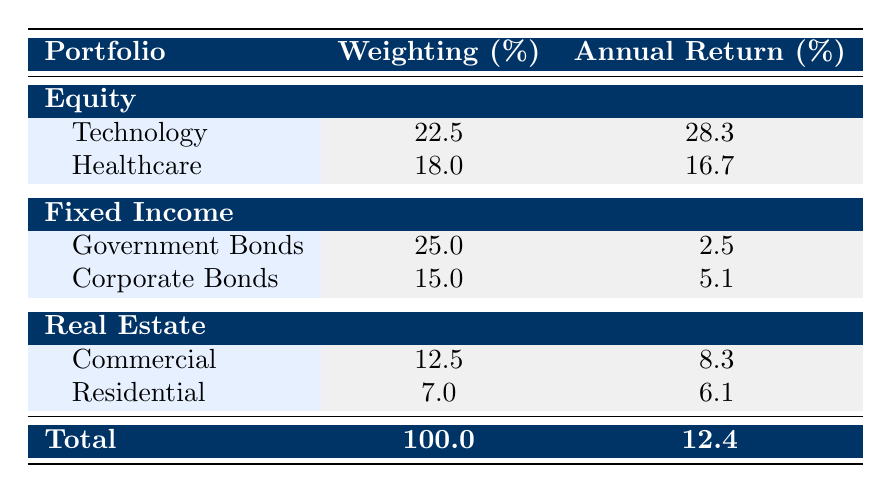What is the annual return percentage for the Technology sector in the Equity portfolio? The annual return percentage for the Technology sector can be found directly in the table under the Equity portfolio section. It shows 28.3% for Technology.
Answer: 28.3% Which sector has the highest weighting percentage in the Fixed Income portfolio? Under the Fixed Income portfolio, the sectors listed are Government Bonds with a weighting of 25.0% and Corporate Bonds with a weighting of 15.0%. Since 25.0% is greater than 15.0%, Government Bonds has the highest weighting percentage.
Answer: Government Bonds What is the total investment value for the Healthcare sector in the Equity portfolio? In the Healthcare sector, the funds listed are Johnson & Johnson ($1,100,000), Pfizer Inc. ($900,000), and Moderna Inc. ($800,000). Adding these values gives a total of $1,100,000 + $900,000 + $800,000 = $2,800,000.
Answer: 2800000 Is the annual return for Corporate Bonds higher than that for Government Bonds in the Fixed Income portfolio? The annual return percentage for Corporate Bonds is 5.1%, while for Government Bonds it is 2.5%. Since 5.1% is greater than 2.5%, we can conclude that Corporate Bonds do have a higher return.
Answer: Yes What is the average annual return percentage for the sectors in the Real Estate portfolio? The Real Estate portfolio has two sectors: Commercial with an annual return of 8.3% and Residential with an annual return of 6.1%. To find the average, we sum the returns (8.3% + 6.1%) and divide by 2, which gives (14.4% / 2) = 7.2%.
Answer: 7.2% Which portfolio contributes the least to the overall annual return of the total investment? The overall annual return is 12.4%. The portfolios are Equity (28.3% as the highest), Fixed Income (2.5% as the lowest), and Real Estate (average somewhere between its sectors). The sector with the lowest return is Fixed Income, specifically from Government Bonds at 2.5%. This confirms that Fixed Income contributes the least to the overall return.
Answer: Fixed Income What is the total investment in the Equity portfolio? The total investment in the Equity portfolio can be found by adding the investment values of the funds in the Technology and Healthcare sectors. The values are $1,500,000 (Apple Inc.) + $1,300,000 (Microsoft) + $1,200,000 (Alphabet) + $1,100,000 (Johnson & Johnson) + $900,000 (Pfizer) + $800,000 (Moderna). The total is $7,300,000.
Answer: 7300000 Is the total return percentage from the Real Estate sector greater than 6%? The average return percentage for Real Estate is calculated as 7.2% (based on Commercial and Residential calculated previously), which is indeed greater than 6%.
Answer: Yes What amount is invested in the lowest-return fund within the Fixed Income portfolio? The funds under the Fixed Income portfolio are US Treasury Bond ($2,000,000), UK Gilt ($800,000), and Corporate Bonds which have their own funds. The lowest annual return is from US Treasury Bond at 1.5% with an investment value of $2,000,000. Hence, this is the lowest-return fund.
Answer: 2000000 